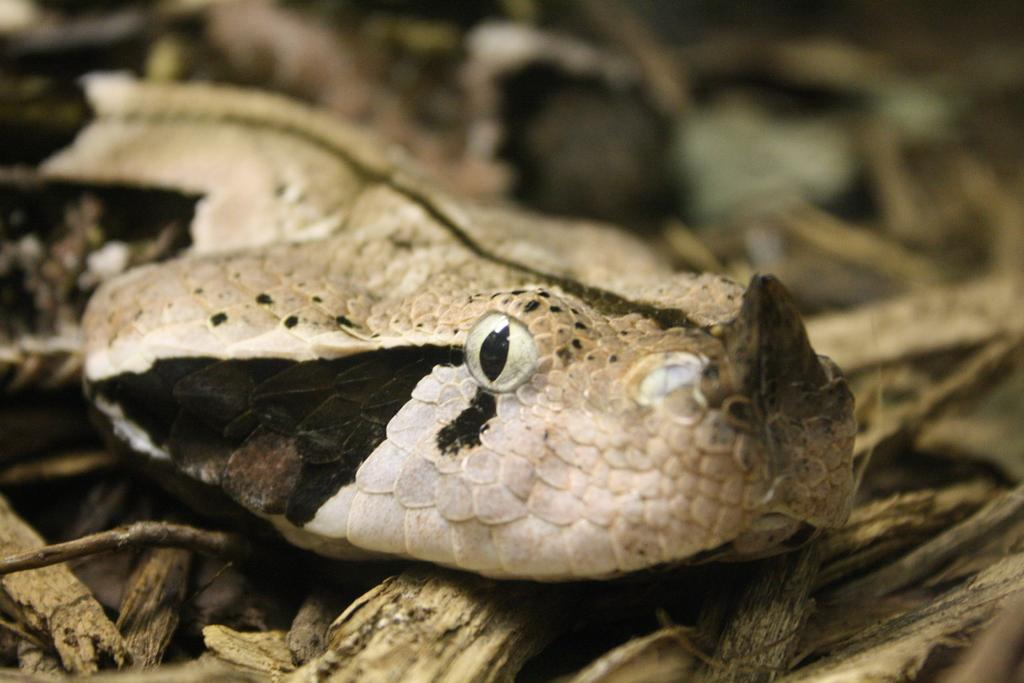What is the main subject in the foreground of the image? There is a snake in the foreground of the image. What else can be seen in the foreground of the image besides the snake? There are dry stems in the foreground of the image. How does the group of deer interact with the snake in the image? There are no deer present in the image, so they cannot interact with the snake. 